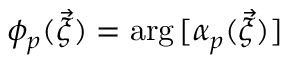Convert formula to latex. <formula><loc_0><loc_0><loc_500><loc_500>\phi _ { p } ( \vec { \xi } ) = \arg { [ { \alpha } _ { p } ( \vec { \xi } ) ] }</formula> 